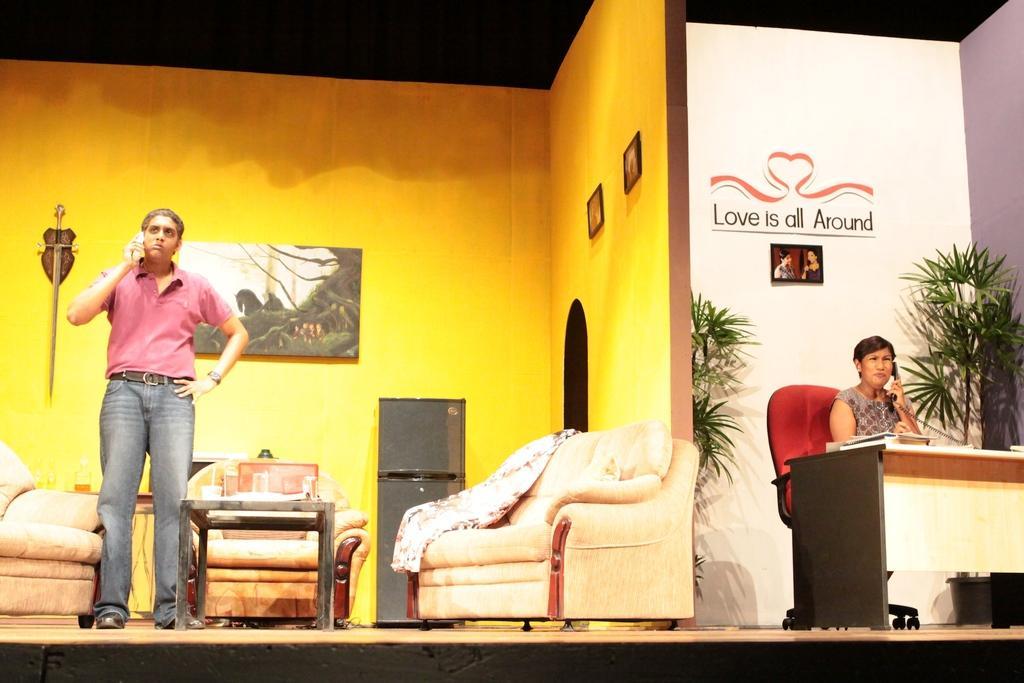In one or two sentences, can you explain what this image depicts? In this image on the right side there is a table and there is a woman sitting on the chair and talking on the telephone and there are plants behind the woman. On the left side there is a man standing and speaking on the phone and there are sofas and there is a table, on the table there are objects. In the background there is a frame on the wall and there is a fridge and on the right side there are frames on the wall. 